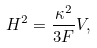<formula> <loc_0><loc_0><loc_500><loc_500>H ^ { 2 } = \frac { \kappa ^ { 2 } } { 3 F } V ,</formula> 